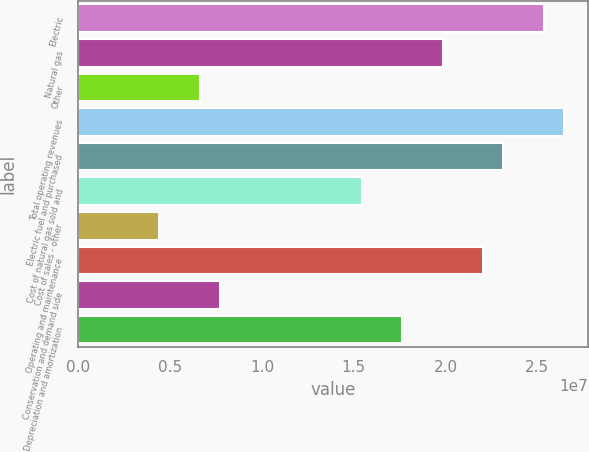Convert chart. <chart><loc_0><loc_0><loc_500><loc_500><bar_chart><fcel>Electric<fcel>Natural gas<fcel>Other<fcel>Total operating revenues<fcel>Electric fuel and purchased<fcel>Cost of natural gas sold and<fcel>Cost of sales - other<fcel>Operating and maintenance<fcel>Conservation and demand side<fcel>Depreciation and amortization<nl><fcel>2.53563e+07<fcel>1.98441e+07<fcel>6.61469e+06<fcel>2.64588e+07<fcel>2.31514e+07<fcel>1.54343e+07<fcel>4.4098e+06<fcel>2.2049e+07<fcel>7.71714e+06<fcel>1.76392e+07<nl></chart> 